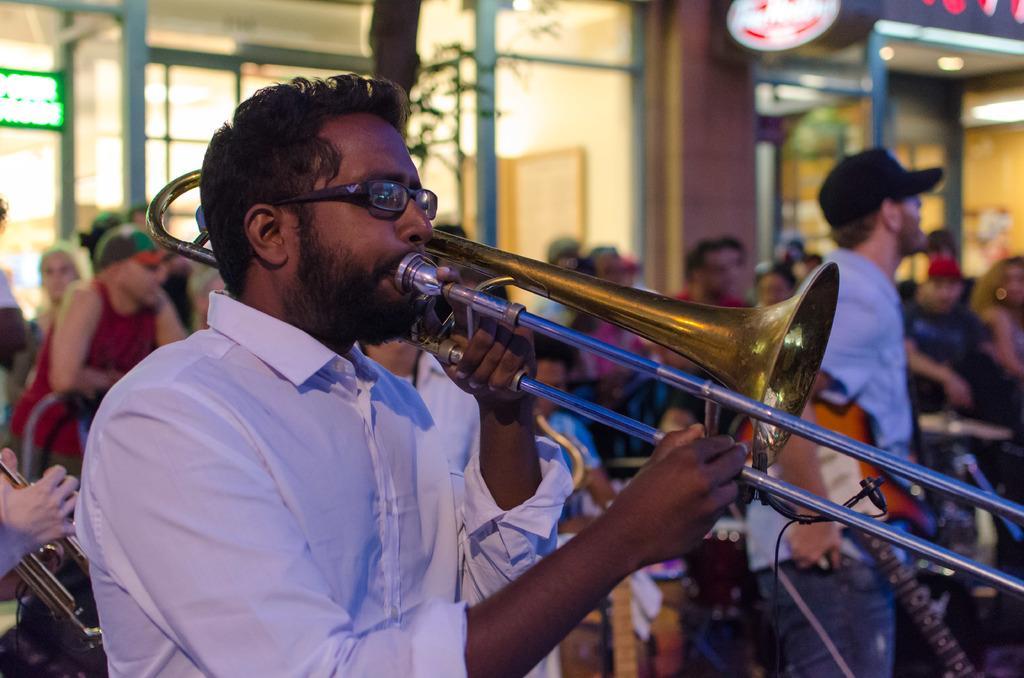Please provide a concise description of this image. In this image, we can see a person wearing clothes and playing a musical instrument. There is an another person on the right side of the image standing and holding a guitar with his hand. In the background, image is blurred. 